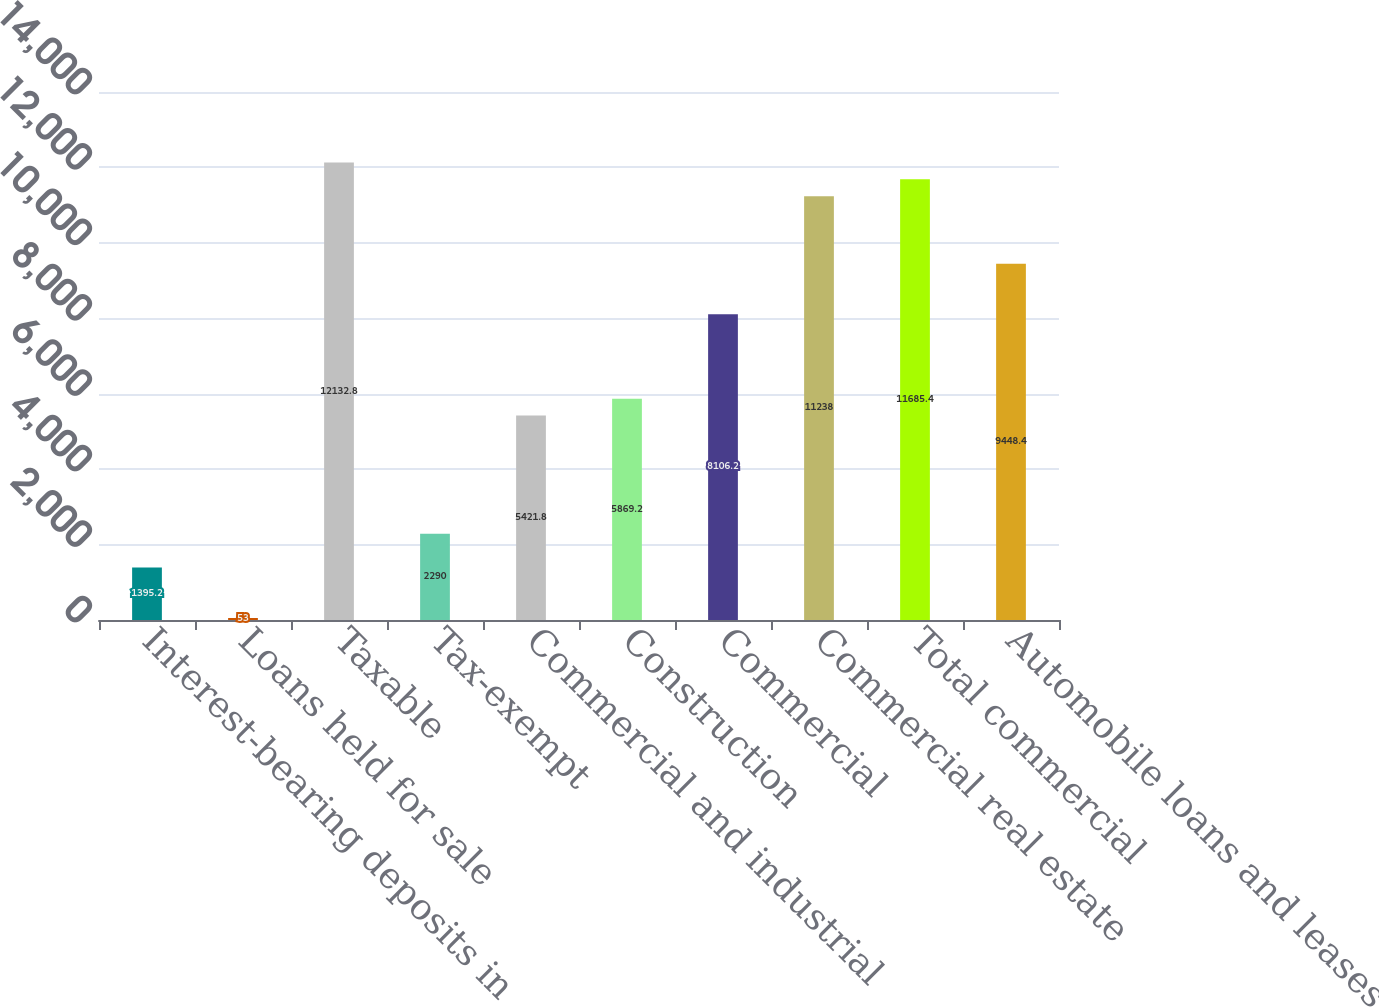<chart> <loc_0><loc_0><loc_500><loc_500><bar_chart><fcel>Interest-bearing deposits in<fcel>Loans held for sale<fcel>Taxable<fcel>Tax-exempt<fcel>Commercial and industrial<fcel>Construction<fcel>Commercial<fcel>Commercial real estate<fcel>Total commercial<fcel>Automobile loans and leases<nl><fcel>1395.2<fcel>53<fcel>12132.8<fcel>2290<fcel>5421.8<fcel>5869.2<fcel>8106.2<fcel>11238<fcel>11685.4<fcel>9448.4<nl></chart> 